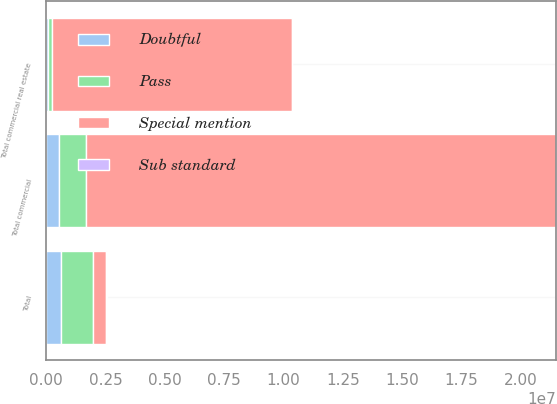<chart> <loc_0><loc_0><loc_500><loc_500><stacked_bar_chart><ecel><fcel>Total commercial<fcel>Total commercial real estate<fcel>Total<nl><fcel>Special mention<fcel>1.98022e+07<fcel>1.0106e+07<fcel>544797<nl><fcel>Doubtful<fcel>544797<fcel>89593<fcel>634390<nl><fcel>Pass<fcel>1.1319e+06<fcel>151580<fcel>1.3591e+06<nl><fcel>Sub standard<fcel>155<fcel>8772<fcel>8927<nl></chart> 